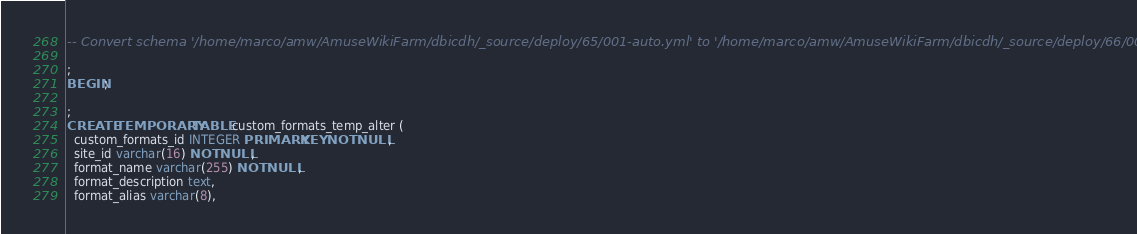Convert code to text. <code><loc_0><loc_0><loc_500><loc_500><_SQL_>-- Convert schema '/home/marco/amw/AmuseWikiFarm/dbicdh/_source/deploy/65/001-auto.yml' to '/home/marco/amw/AmuseWikiFarm/dbicdh/_source/deploy/66/001-auto.yml':;

;
BEGIN;

;
CREATE TEMPORARY TABLE custom_formats_temp_alter (
  custom_formats_id INTEGER PRIMARY KEY NOT NULL,
  site_id varchar(16) NOT NULL,
  format_name varchar(255) NOT NULL,
  format_description text,
  format_alias varchar(8),</code> 